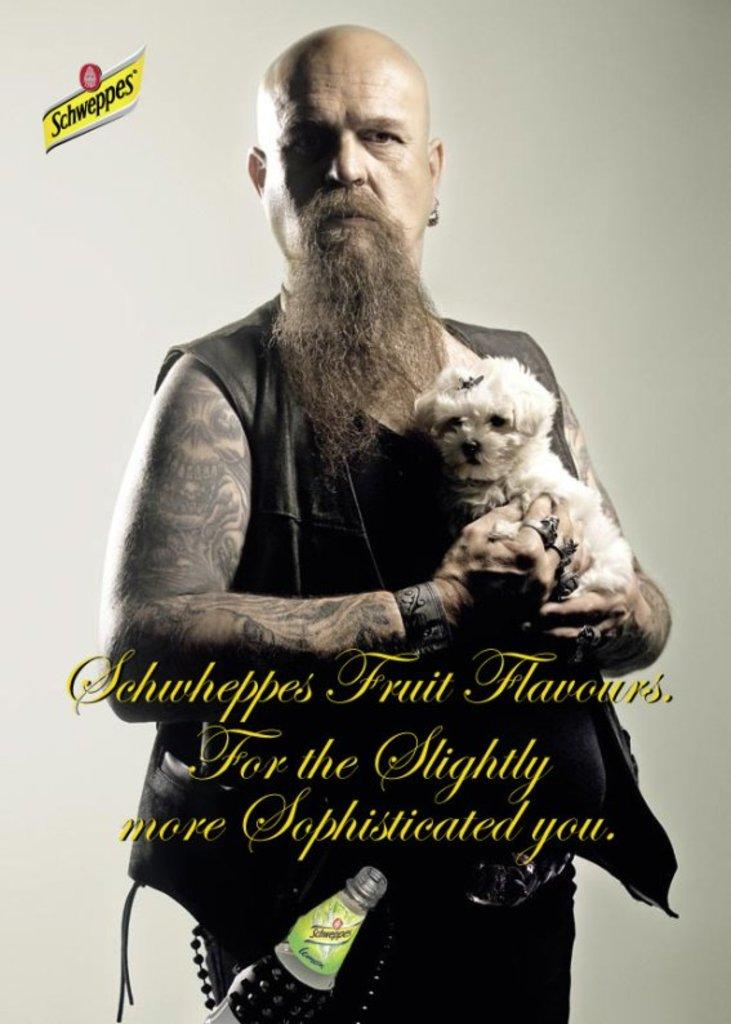What is the main subject of the image? The main subject of the image is a man. What is the man wearing in the image? The man is wearing a vest coat in the image. What is the man holding in the image? The man is holding a puppy in the image. Can you describe the man's facial hair in the image? The man has a long beard in the image. What is the man's hairstyle in the image? The man has a bald head in the image. What else can be seen in the man's pocket in the image? The man has a bottle in his pocket in the image. What type of train can be seen in the background of the image? There is no train visible in the image. What is the taste of the puppy in the image? The puppy is not a food item, so it does not have a taste. 